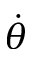<formula> <loc_0><loc_0><loc_500><loc_500>\dot { \theta }</formula> 